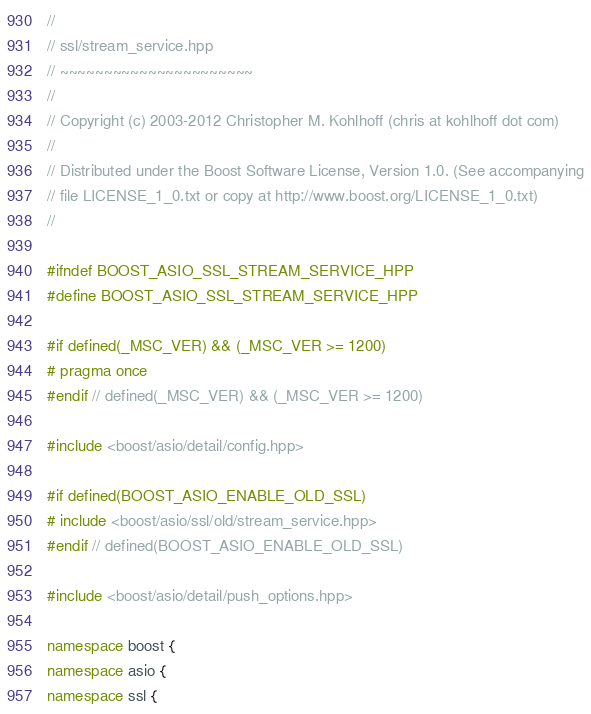Convert code to text. <code><loc_0><loc_0><loc_500><loc_500><_C++_>//
// ssl/stream_service.hpp
// ~~~~~~~~~~~~~~~~~~~~~~
//
// Copyright (c) 2003-2012 Christopher M. Kohlhoff (chris at kohlhoff dot com)
//
// Distributed under the Boost Software License, Version 1.0. (See accompanying
// file LICENSE_1_0.txt or copy at http://www.boost.org/LICENSE_1_0.txt)
//

#ifndef BOOST_ASIO_SSL_STREAM_SERVICE_HPP
#define BOOST_ASIO_SSL_STREAM_SERVICE_HPP

#if defined(_MSC_VER) && (_MSC_VER >= 1200)
# pragma once
#endif // defined(_MSC_VER) && (_MSC_VER >= 1200)

#include <boost/asio/detail/config.hpp>

#if defined(BOOST_ASIO_ENABLE_OLD_SSL)
# include <boost/asio/ssl/old/stream_service.hpp>
#endif // defined(BOOST_ASIO_ENABLE_OLD_SSL)

#include <boost/asio/detail/push_options.hpp>

namespace boost {
namespace asio {
namespace ssl {
</code> 